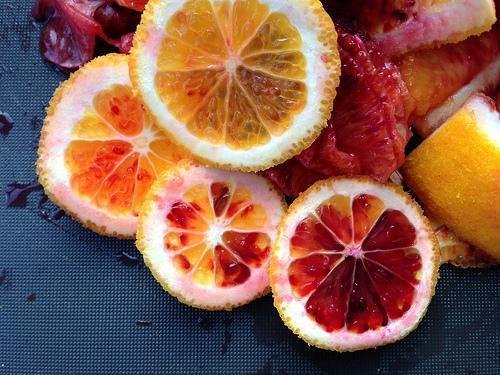How many orange rounds are seen?
Give a very brief answer. 4. 